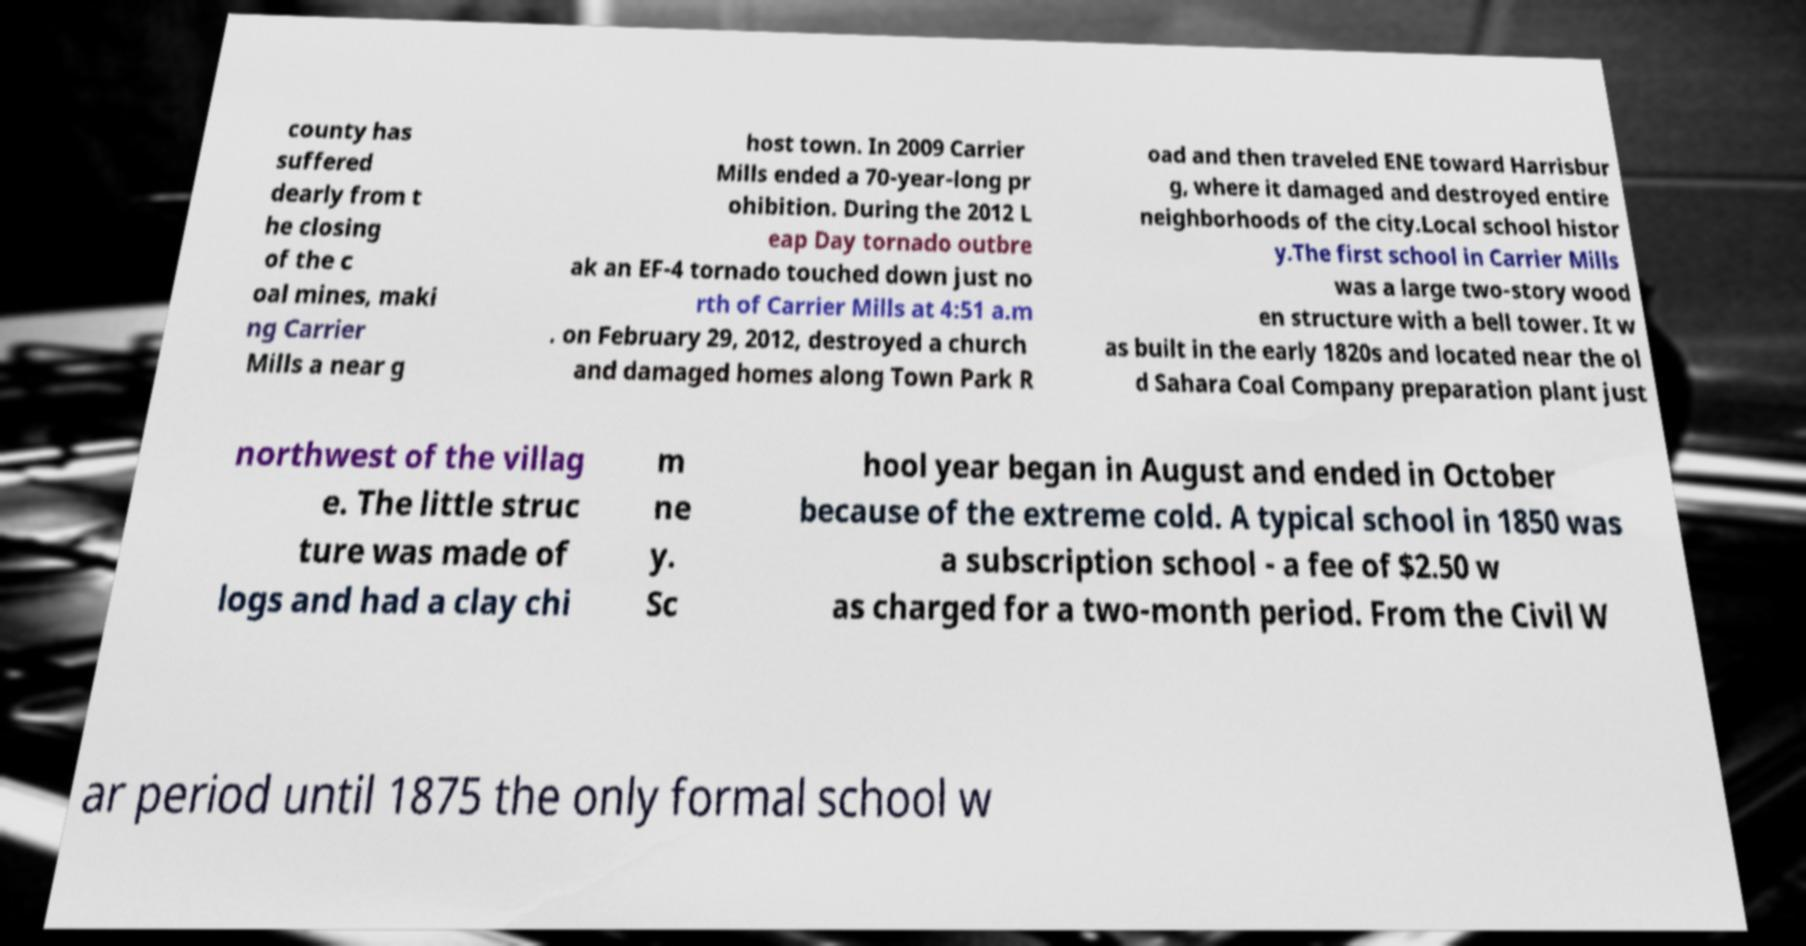Could you assist in decoding the text presented in this image and type it out clearly? county has suffered dearly from t he closing of the c oal mines, maki ng Carrier Mills a near g host town. In 2009 Carrier Mills ended a 70-year-long pr ohibition. During the 2012 L eap Day tornado outbre ak an EF-4 tornado touched down just no rth of Carrier Mills at 4:51 a.m . on February 29, 2012, destroyed a church and damaged homes along Town Park R oad and then traveled ENE toward Harrisbur g, where it damaged and destroyed entire neighborhoods of the city.Local school histor y.The first school in Carrier Mills was a large two-story wood en structure with a bell tower. It w as built in the early 1820s and located near the ol d Sahara Coal Company preparation plant just northwest of the villag e. The little struc ture was made of logs and had a clay chi m ne y. Sc hool year began in August and ended in October because of the extreme cold. A typical school in 1850 was a subscription school - a fee of $2.50 w as charged for a two-month period. From the Civil W ar period until 1875 the only formal school w 